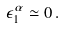<formula> <loc_0><loc_0><loc_500><loc_500>\epsilon ^ { \alpha } _ { 1 } \simeq 0 \, .</formula> 